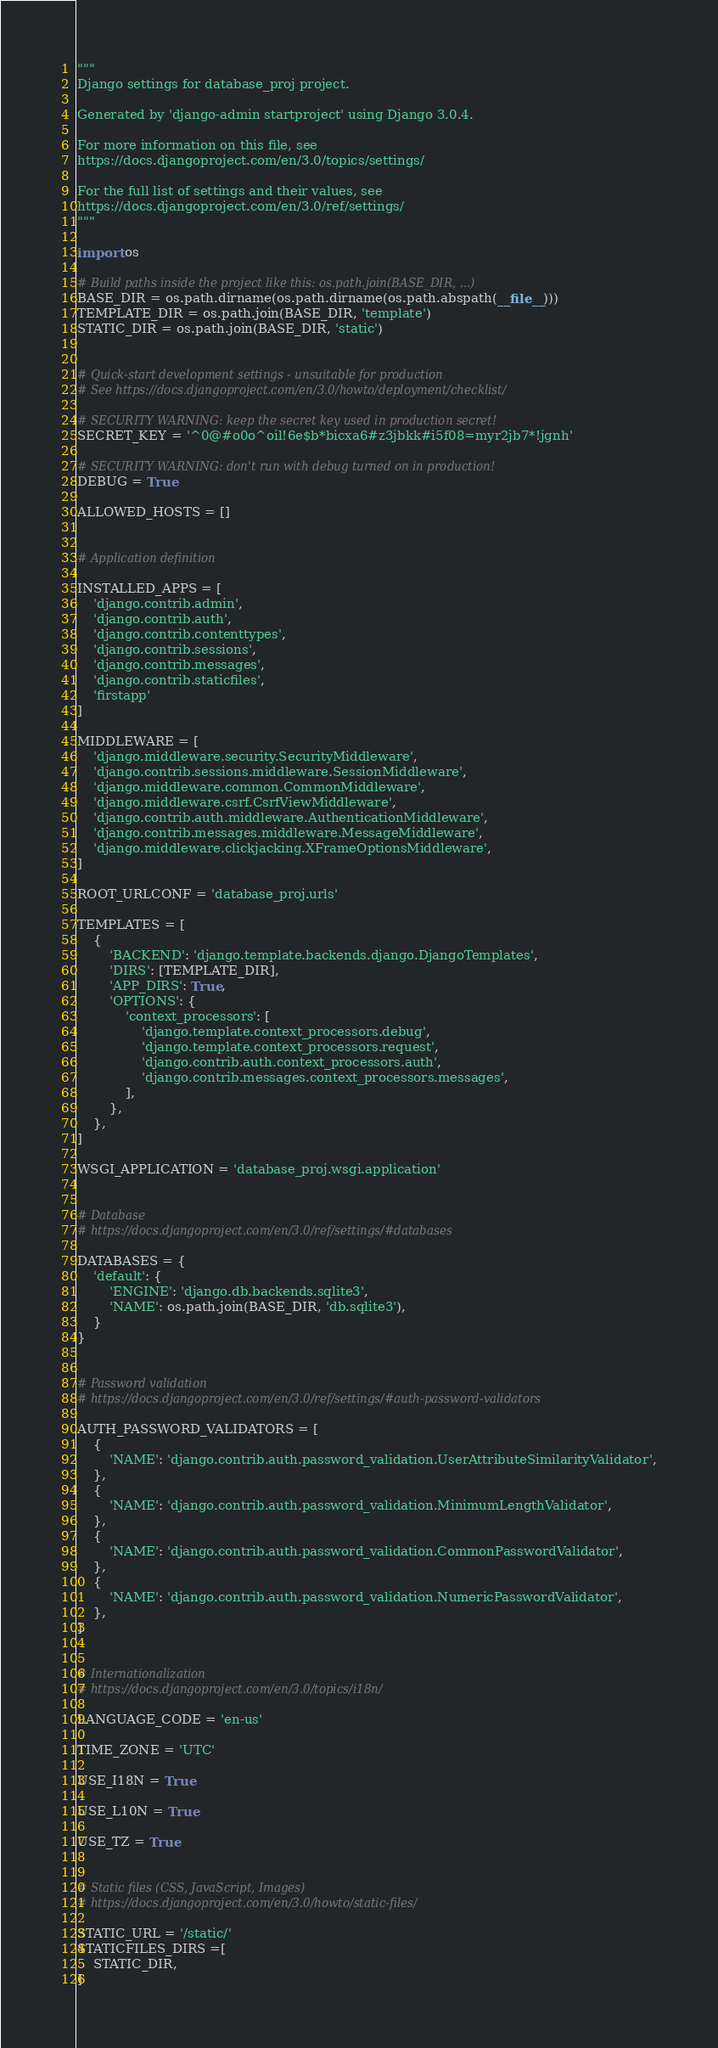Convert code to text. <code><loc_0><loc_0><loc_500><loc_500><_Python_>"""
Django settings for database_proj project.

Generated by 'django-admin startproject' using Django 3.0.4.

For more information on this file, see
https://docs.djangoproject.com/en/3.0/topics/settings/

For the full list of settings and their values, see
https://docs.djangoproject.com/en/3.0/ref/settings/
"""

import os

# Build paths inside the project like this: os.path.join(BASE_DIR, ...)
BASE_DIR = os.path.dirname(os.path.dirname(os.path.abspath(__file__)))
TEMPLATE_DIR = os.path.join(BASE_DIR, 'template')
STATIC_DIR = os.path.join(BASE_DIR, 'static')


# Quick-start development settings - unsuitable for production
# See https://docs.djangoproject.com/en/3.0/howto/deployment/checklist/

# SECURITY WARNING: keep the secret key used in production secret!
SECRET_KEY = '^0@#o0o^oil!6e$b*bicxa6#z3jbkk#i5f08=myr2jb7*!jgnh'

# SECURITY WARNING: don't run with debug turned on in production!
DEBUG = True

ALLOWED_HOSTS = []


# Application definition

INSTALLED_APPS = [
    'django.contrib.admin',
    'django.contrib.auth',
    'django.contrib.contenttypes',
    'django.contrib.sessions',
    'django.contrib.messages',
    'django.contrib.staticfiles',
    'firstapp'
]

MIDDLEWARE = [
    'django.middleware.security.SecurityMiddleware',
    'django.contrib.sessions.middleware.SessionMiddleware',
    'django.middleware.common.CommonMiddleware',
    'django.middleware.csrf.CsrfViewMiddleware',
    'django.contrib.auth.middleware.AuthenticationMiddleware',
    'django.contrib.messages.middleware.MessageMiddleware',
    'django.middleware.clickjacking.XFrameOptionsMiddleware',
]

ROOT_URLCONF = 'database_proj.urls'

TEMPLATES = [
    {
        'BACKEND': 'django.template.backends.django.DjangoTemplates',
        'DIRS': [TEMPLATE_DIR],
        'APP_DIRS': True,
        'OPTIONS': {
            'context_processors': [
                'django.template.context_processors.debug',
                'django.template.context_processors.request',
                'django.contrib.auth.context_processors.auth',
                'django.contrib.messages.context_processors.messages',
            ],
        },
    },
]

WSGI_APPLICATION = 'database_proj.wsgi.application'


# Database
# https://docs.djangoproject.com/en/3.0/ref/settings/#databases

DATABASES = {
    'default': {
        'ENGINE': 'django.db.backends.sqlite3',
        'NAME': os.path.join(BASE_DIR, 'db.sqlite3'),
    }
}


# Password validation
# https://docs.djangoproject.com/en/3.0/ref/settings/#auth-password-validators

AUTH_PASSWORD_VALIDATORS = [
    {
        'NAME': 'django.contrib.auth.password_validation.UserAttributeSimilarityValidator',
    },
    {
        'NAME': 'django.contrib.auth.password_validation.MinimumLengthValidator',
    },
    {
        'NAME': 'django.contrib.auth.password_validation.CommonPasswordValidator',
    },
    {
        'NAME': 'django.contrib.auth.password_validation.NumericPasswordValidator',
    },
]


# Internationalization
# https://docs.djangoproject.com/en/3.0/topics/i18n/

LANGUAGE_CODE = 'en-us'

TIME_ZONE = 'UTC'

USE_I18N = True

USE_L10N = True

USE_TZ = True


# Static files (CSS, JavaScript, Images)
# https://docs.djangoproject.com/en/3.0/howto/static-files/

STATIC_URL = '/static/'
STATICFILES_DIRS =[
    STATIC_DIR,
]
</code> 